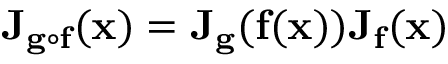<formula> <loc_0><loc_0><loc_500><loc_500>J _ { g \circ f } ( x ) = J _ { g } ( f ( x ) ) J _ { f } ( x )</formula> 